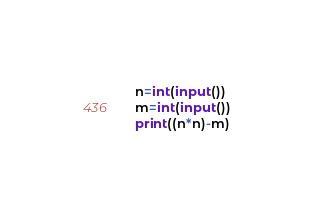Convert code to text. <code><loc_0><loc_0><loc_500><loc_500><_Python_>n=int(input())
m=int(input())
print((n*n)-m)
</code> 